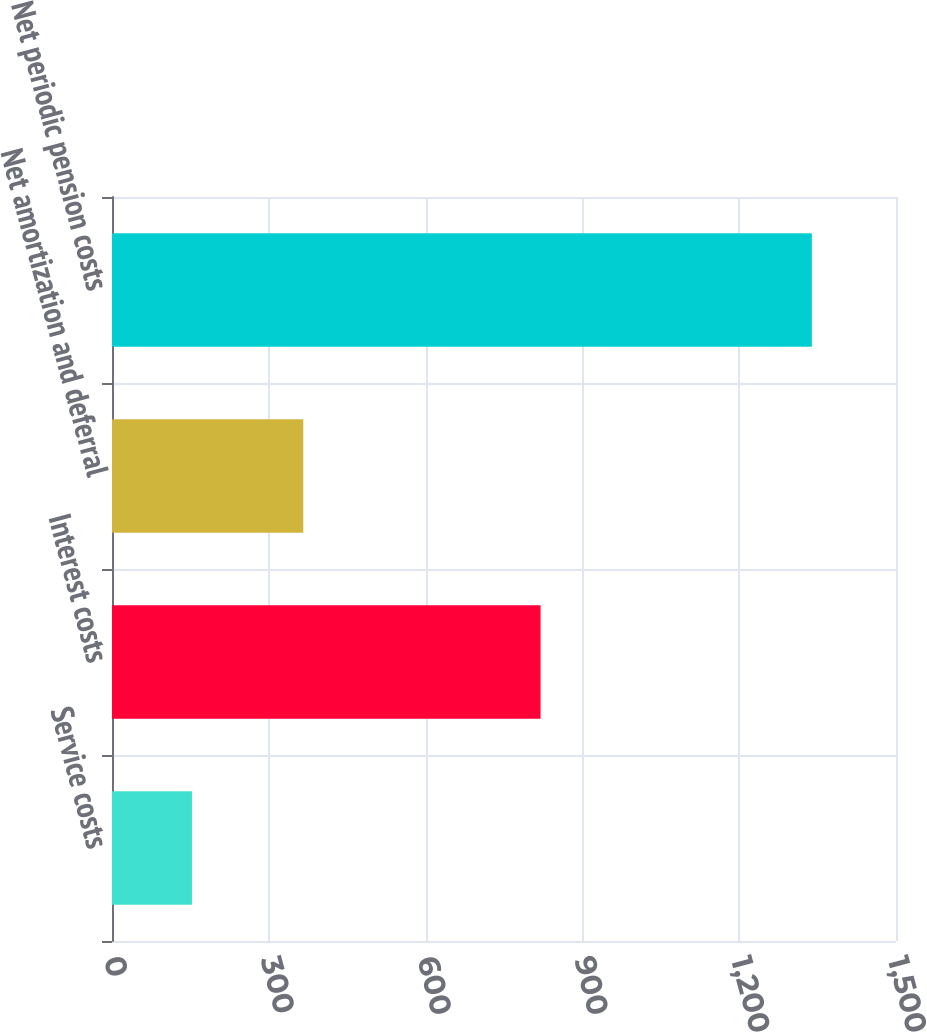Convert chart. <chart><loc_0><loc_0><loc_500><loc_500><bar_chart><fcel>Service costs<fcel>Interest costs<fcel>Net amortization and deferral<fcel>Net periodic pension costs<nl><fcel>153<fcel>820<fcel>366<fcel>1339<nl></chart> 